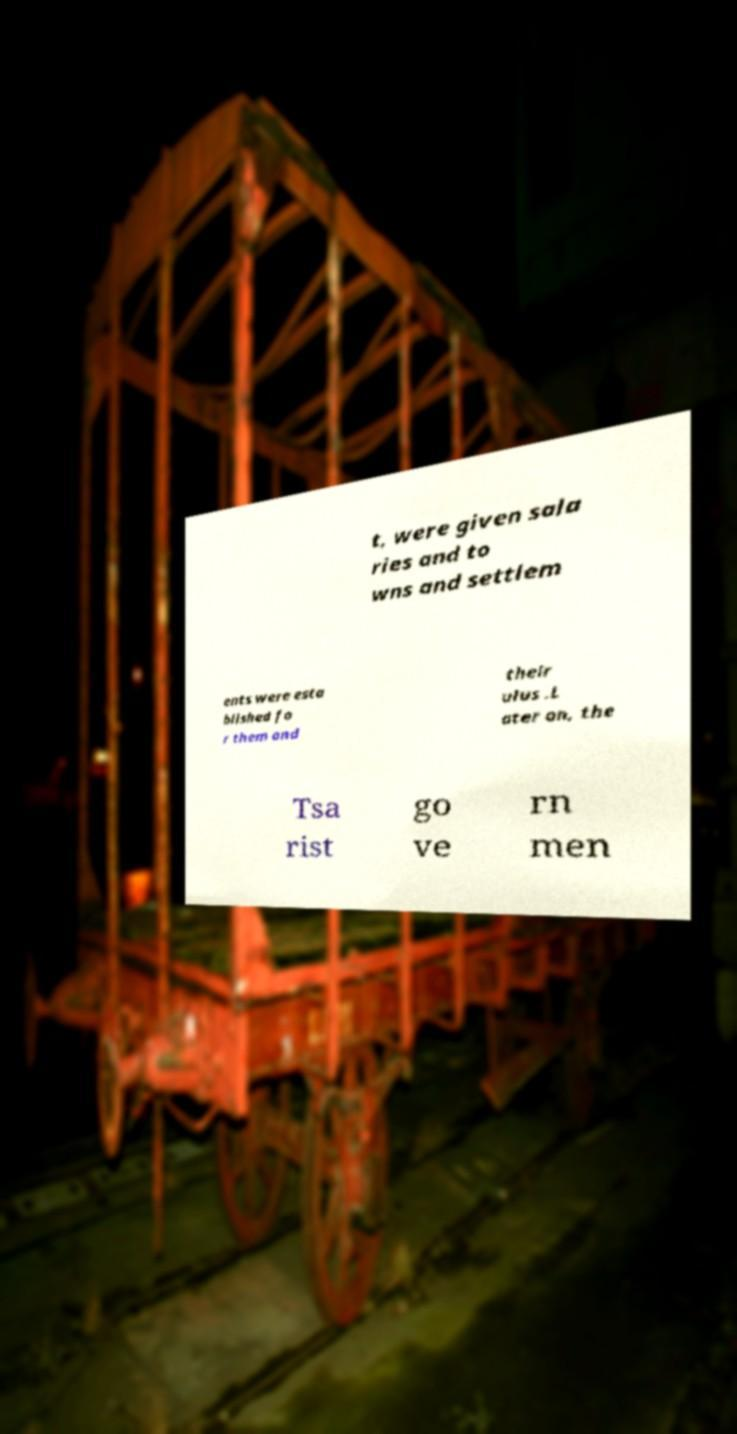Can you accurately transcribe the text from the provided image for me? t, were given sala ries and to wns and settlem ents were esta blished fo r them and their ulus .L ater on, the Tsa rist go ve rn men 